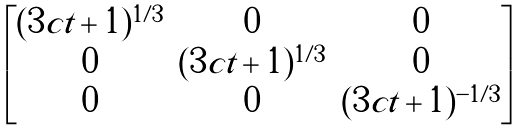Convert formula to latex. <formula><loc_0><loc_0><loc_500><loc_500>\begin{bmatrix} ( 3 c t + 1 ) ^ { 1 / 3 } & 0 & 0 \\ 0 & ( 3 c t + 1 ) ^ { 1 / 3 } & 0 \\ 0 & 0 & ( 3 c t + 1 ) ^ { - 1 / 3 } \\ \end{bmatrix}</formula> 